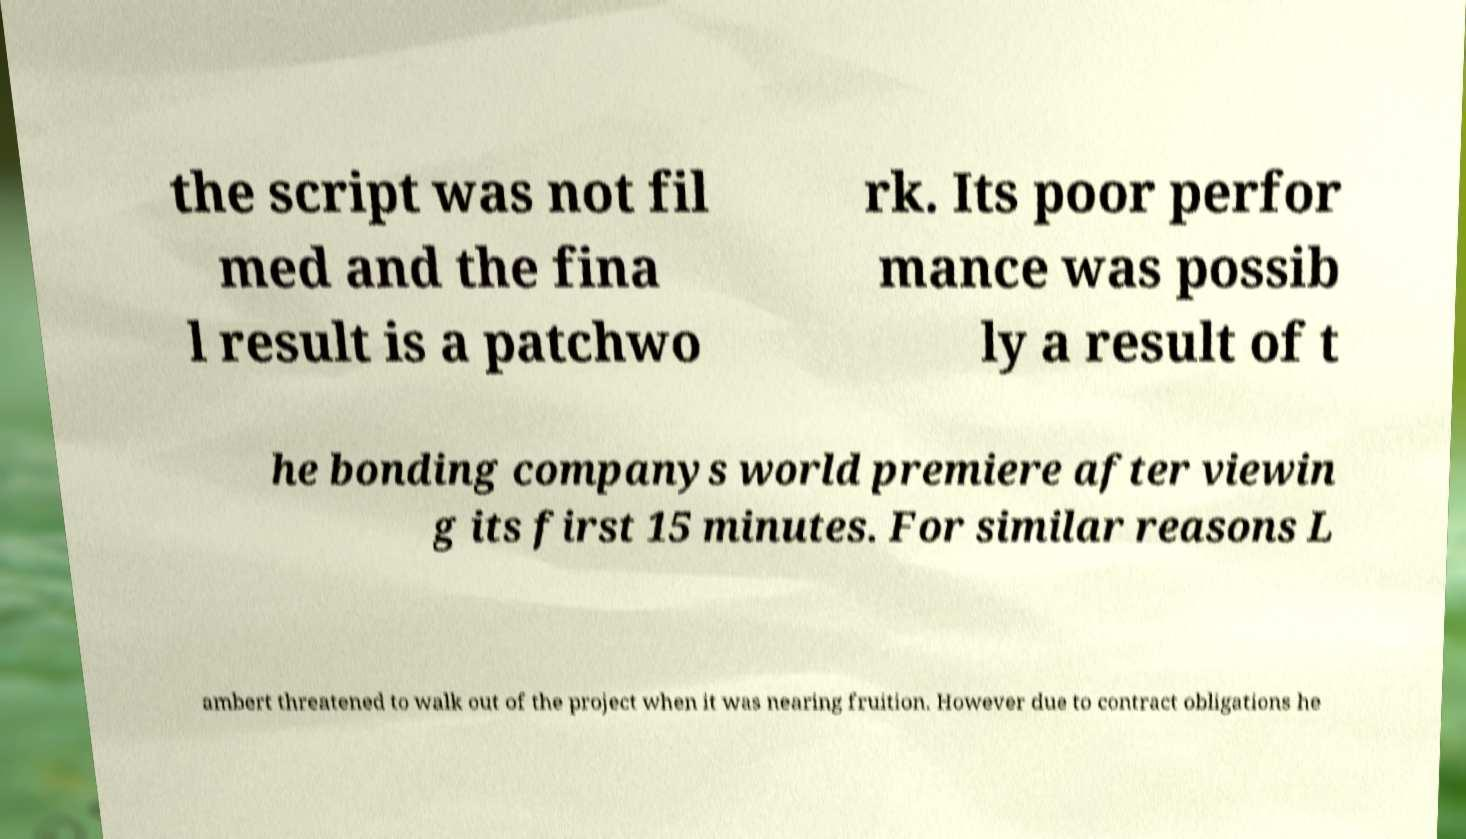Please read and relay the text visible in this image. What does it say? the script was not fil med and the fina l result is a patchwo rk. Its poor perfor mance was possib ly a result of t he bonding companys world premiere after viewin g its first 15 minutes. For similar reasons L ambert threatened to walk out of the project when it was nearing fruition. However due to contract obligations he 